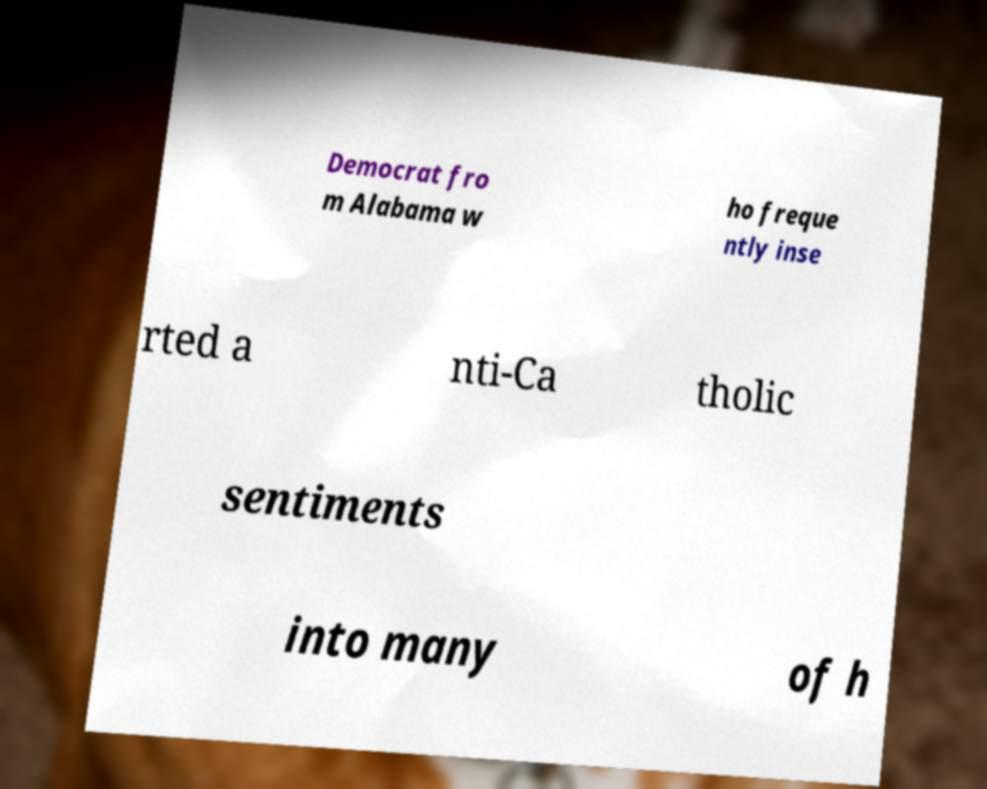What messages or text are displayed in this image? I need them in a readable, typed format. Democrat fro m Alabama w ho freque ntly inse rted a nti-Ca tholic sentiments into many of h 